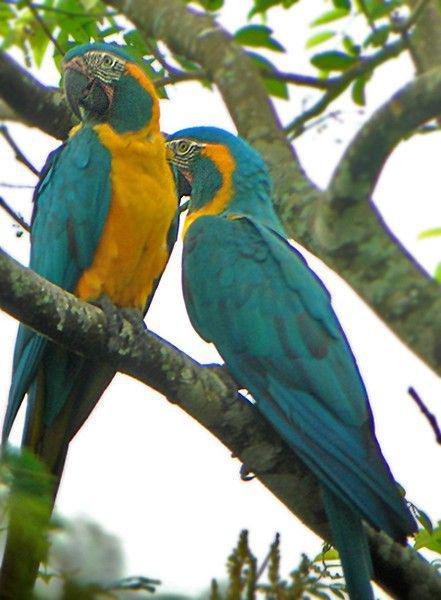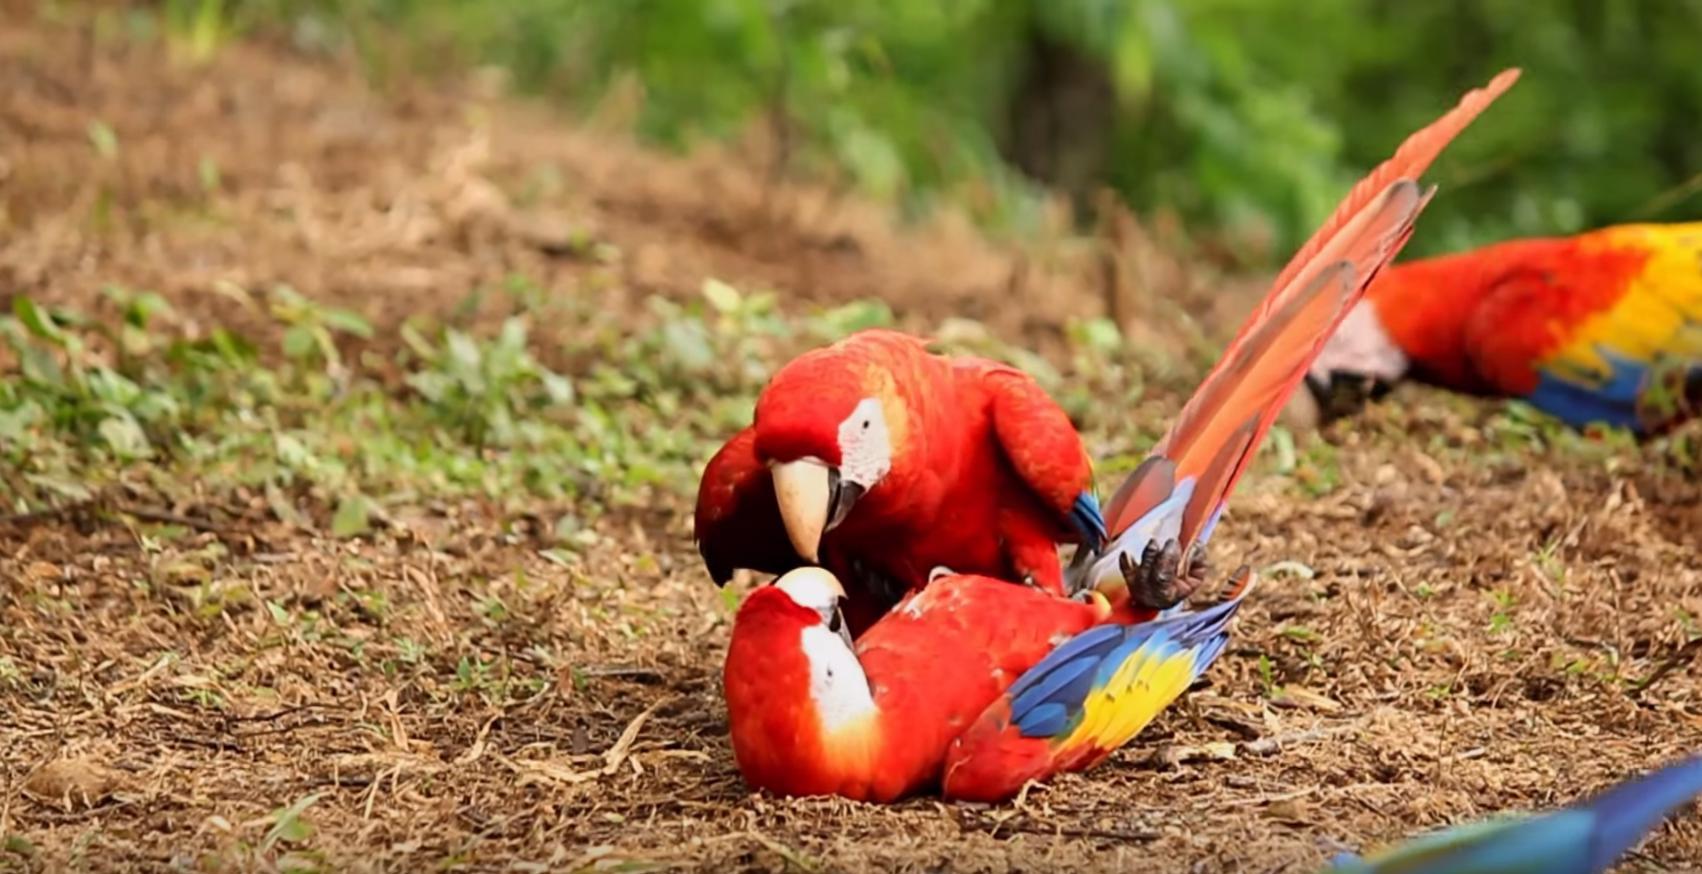The first image is the image on the left, the second image is the image on the right. For the images shown, is this caption "One of the images contains exactly one parrot." true? Answer yes or no. No. 